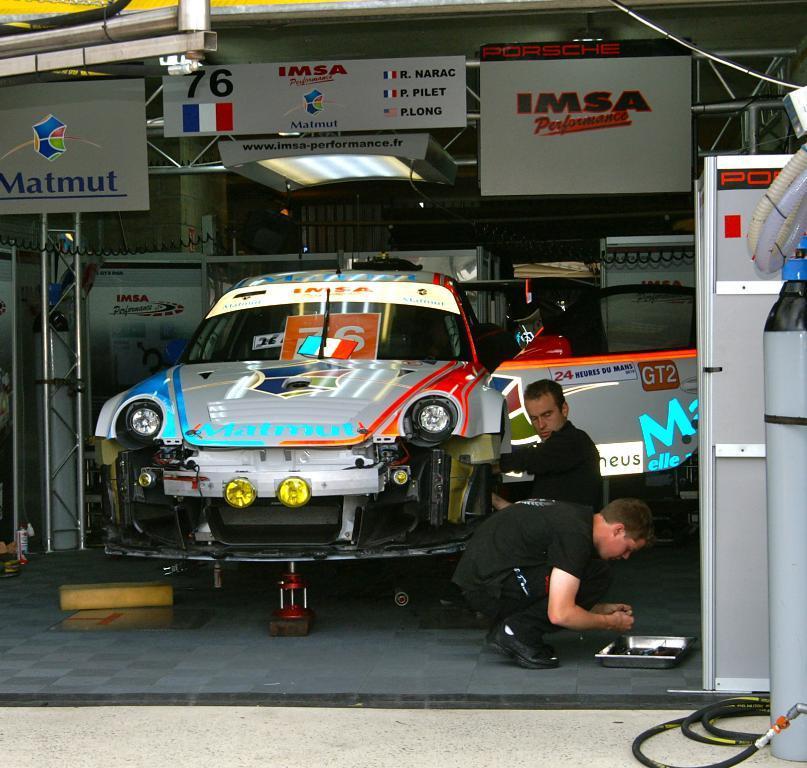Could you give a brief overview of what you see in this image? Man in black t-shirt is repairing white color car which is placed in the garage. Beside him, boy in black t-shirt is holding something in his hand. On the right corner of the picture, we see a white door and we even see gas pump. At the top of the picture, we see white color boards with some text written on it. This picture might be clicked in the garage. 